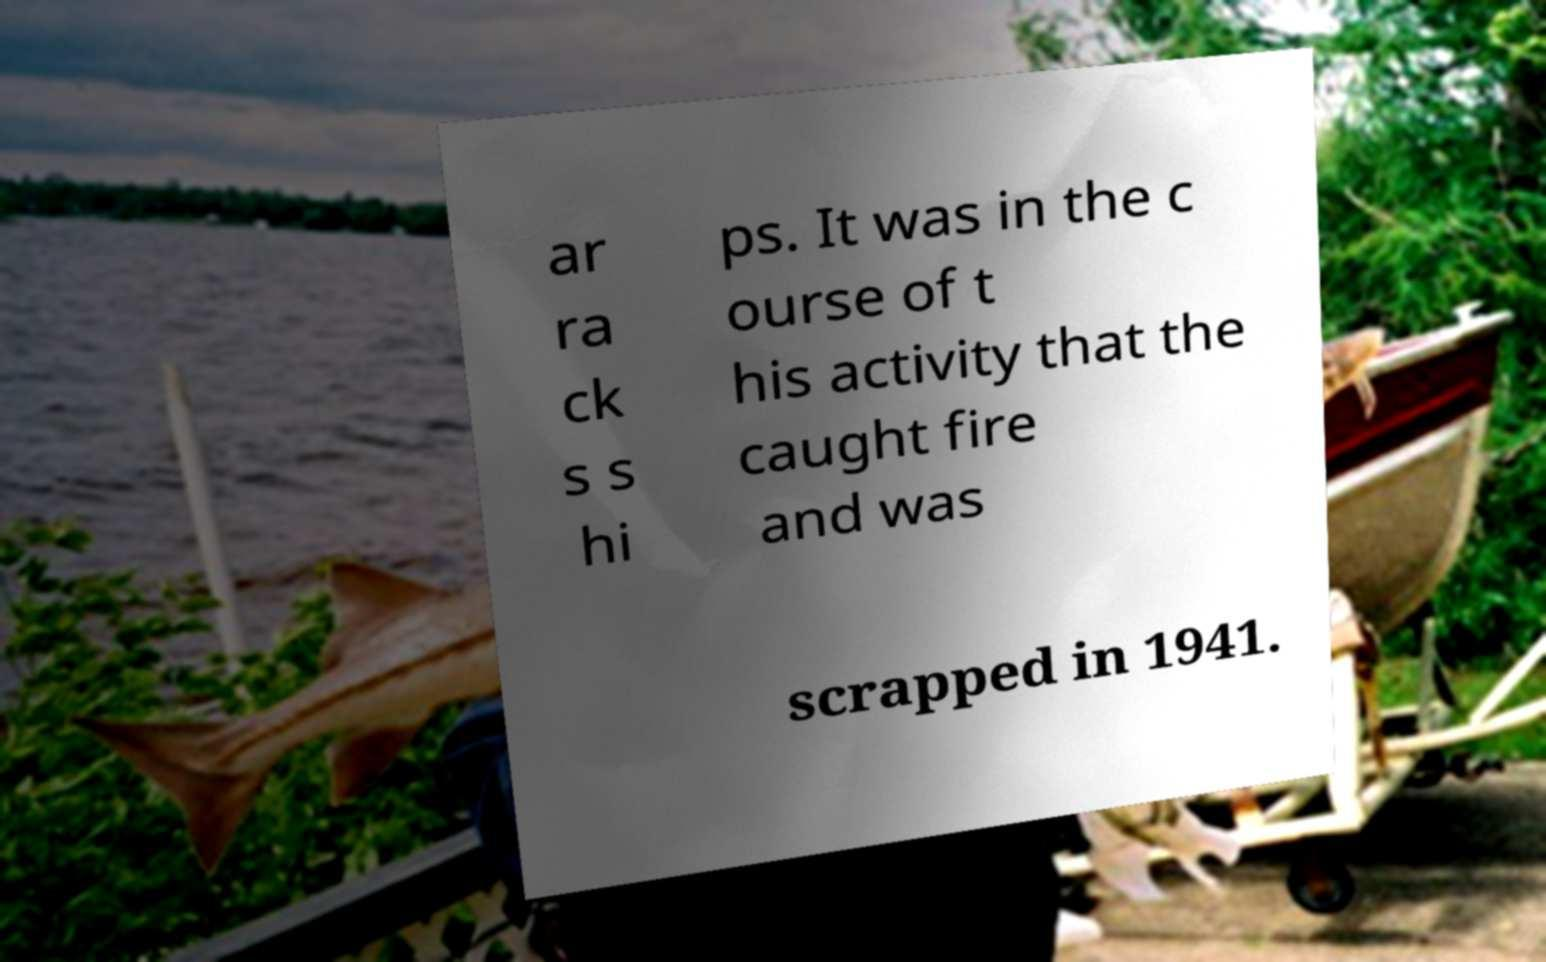Can you read and provide the text displayed in the image?This photo seems to have some interesting text. Can you extract and type it out for me? ar ra ck s s hi ps. It was in the c ourse of t his activity that the caught fire and was scrapped in 1941. 